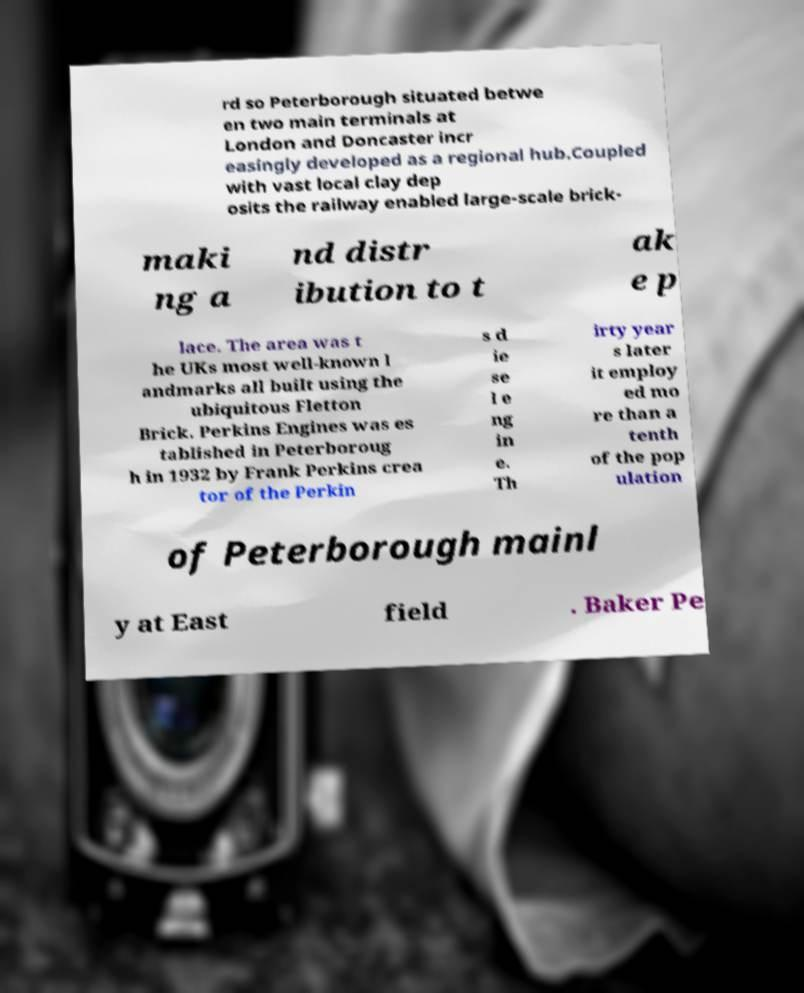Can you read and provide the text displayed in the image?This photo seems to have some interesting text. Can you extract and type it out for me? rd so Peterborough situated betwe en two main terminals at London and Doncaster incr easingly developed as a regional hub.Coupled with vast local clay dep osits the railway enabled large-scale brick- maki ng a nd distr ibution to t ak e p lace. The area was t he UKs most well-known l andmarks all built using the ubiquitous Fletton Brick. Perkins Engines was es tablished in Peterboroug h in 1932 by Frank Perkins crea tor of the Perkin s d ie se l e ng in e. Th irty year s later it employ ed mo re than a tenth of the pop ulation of Peterborough mainl y at East field . Baker Pe 